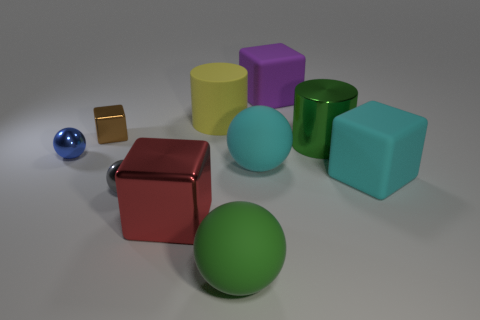Subtract 1 blocks. How many blocks are left? 3 Subtract all spheres. How many objects are left? 6 Add 4 green metal cylinders. How many green metal cylinders exist? 5 Subtract 0 gray cylinders. How many objects are left? 10 Subtract all tiny green shiny cylinders. Subtract all tiny blue metal things. How many objects are left? 9 Add 2 tiny brown shiny objects. How many tiny brown shiny objects are left? 3 